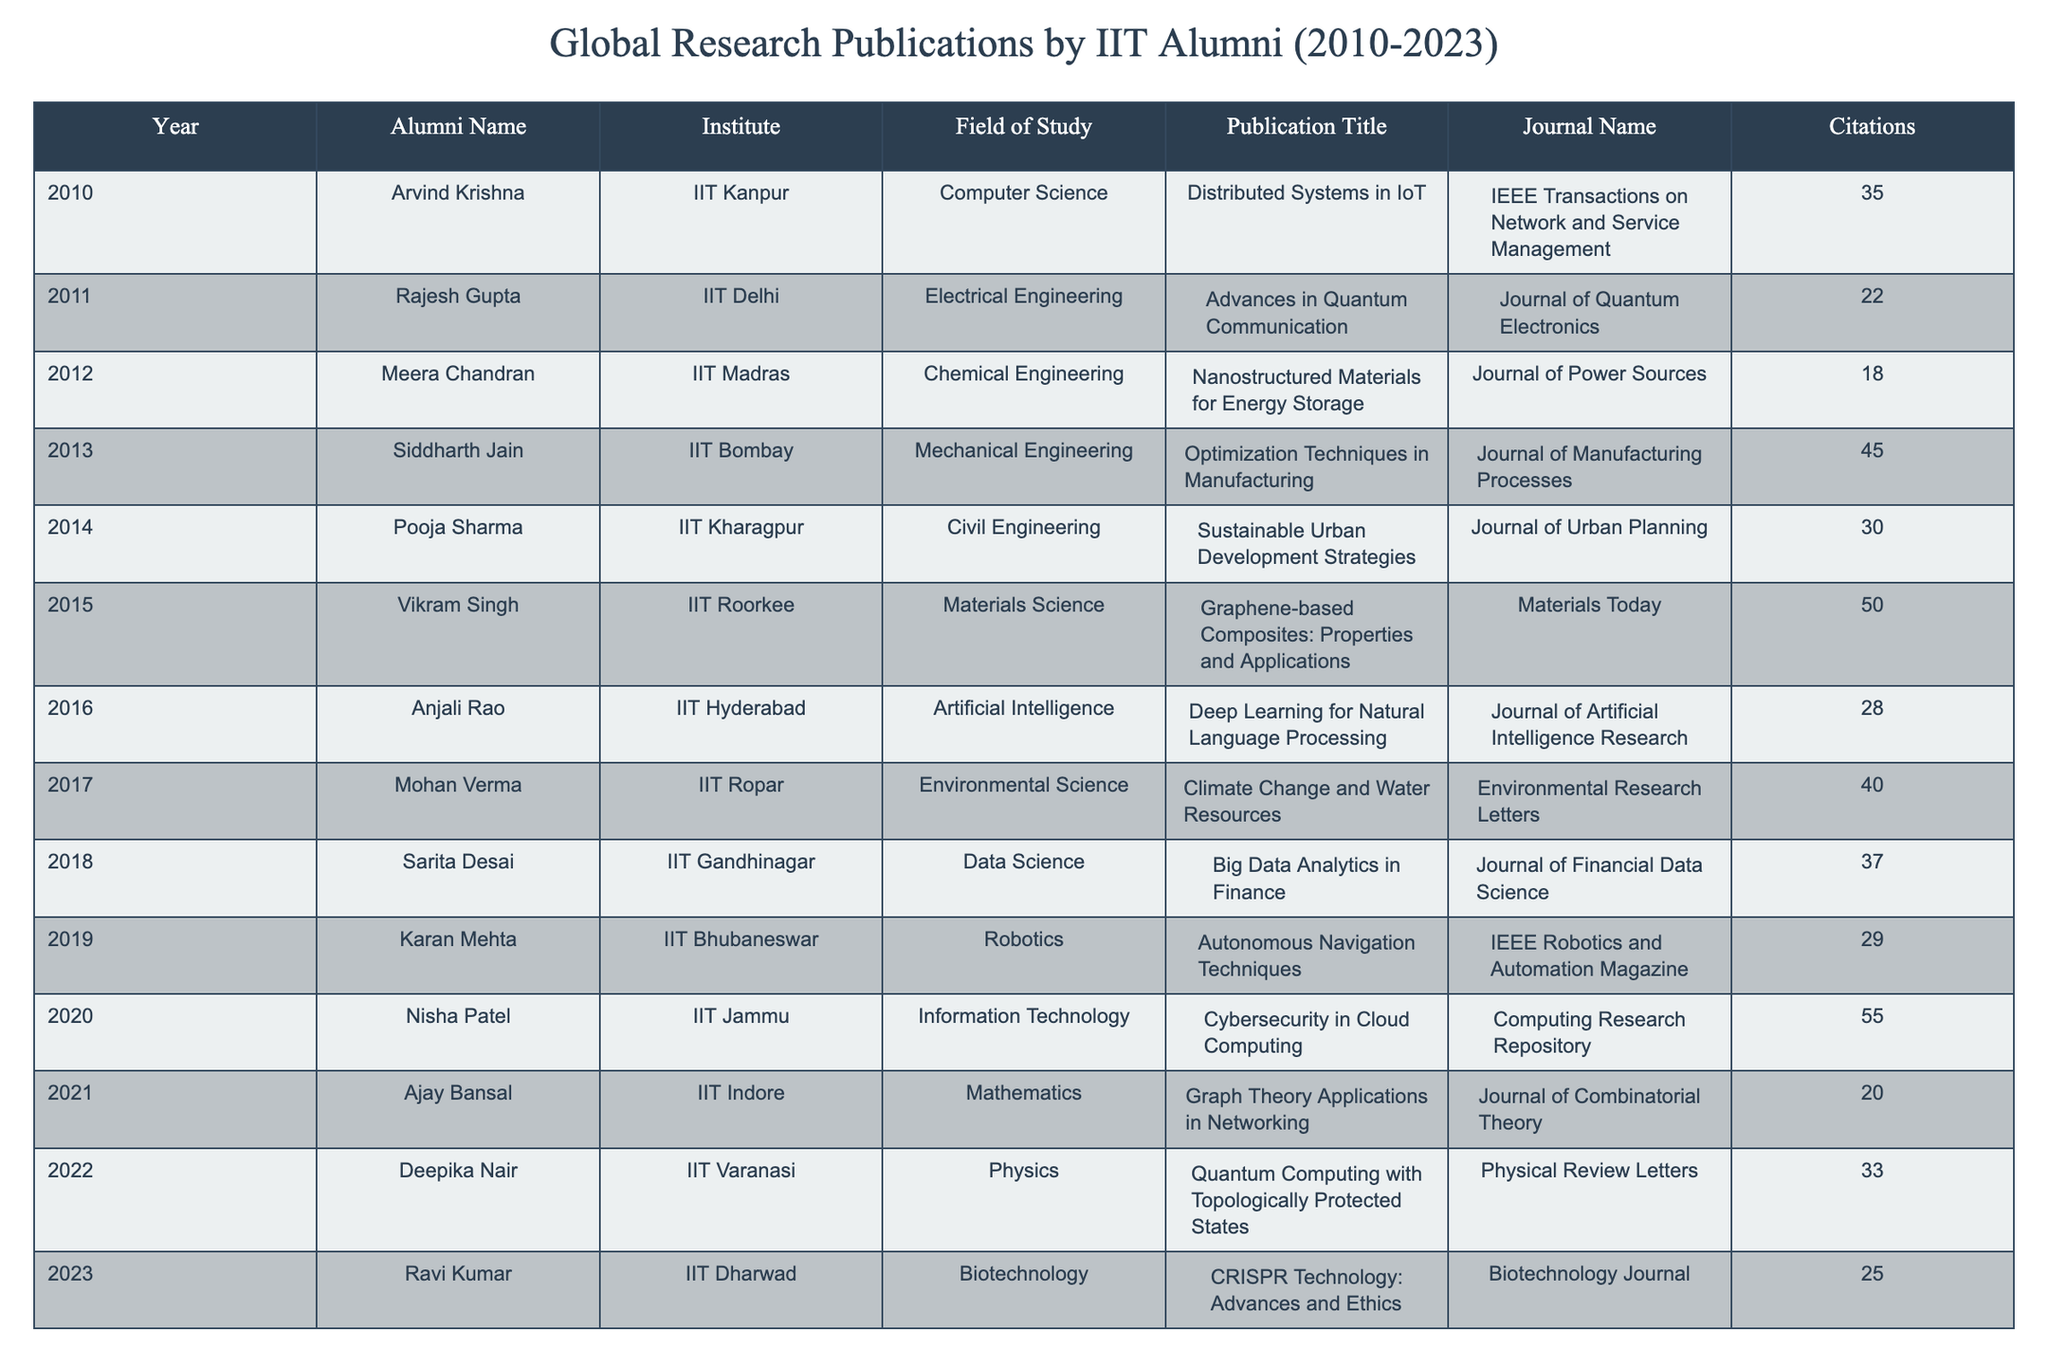What is the publication title by Arvind Krishna? The table lists the publication titles associated with each alumnus. For Arvind Krishna, the publication title under his record is "Distributed Systems in IoT."
Answer: Distributed Systems in IoT Which institute did Nisha Patel attend? By checking the row corresponding to Nisha Patel, we see that her institute is IIT Jammu.
Answer: IIT Jammu How many citations did Vikram Singh receive for his publication? Referring to Vikram Singh's record, the citations column shows that he received 50 citations.
Answer: 50 Can you name the publication that has the highest number of citations? To find this, we check the citations for each publication. The publication by Nisha Patel has the highest citations with a total of 55.
Answer: Cybersecurity in Cloud Computing What is the average number of citations for publications from 2010 to 2023? We sum all citations: 35 + 22 + 18 + 45 + 30 + 50 + 28 + 40 + 37 + 29 + 55 + 20 + 33 + 25 =  397. There are 14 publications, so the average is 397/14 ≈ 28.36.
Answer: 28.36 Was there a publication from IIT Dharwad before 2023? Reviewing the data, we find that there is only one entry from IIT Dharwad, which corresponds to the year 2023. Thus, there is no publication from IIT Dharwad before that year.
Answer: No What is the difference in citations between the publication with the highest and the lowest citations? The highest citation count is 55 (Nisha Patel) and the lowest is 18 (Meera Chandran). The difference is 55 - 18 = 37.
Answer: 37 How many fields of study are represented in the publications? By checking the distinct fields listed, we identify the following unique fields: Computer Science, Electrical Engineering, Chemical Engineering, Mechanical Engineering, Civil Engineering, Materials Science, Artificial Intelligence, Environmental Science, Data Science, Robotics, Information Technology, Mathematics, Physics, and Biotechnology, totaling 14 different fields of study.
Answer: 14 Which year had the most notable rise in citations from previous years based on the data provided? Starting from 2010, we track changes in citation counts each year. While looking closely, in 2020, Nisha Patel's work shows a big leap to 55 citations from an average of around 30 in previous years, thus indicating a notable rise.
Answer: 2020 Is there any alumni from IIT Kanpur who published in the field of Artificial Intelligence? Upon checking the records, Arvind Krishna is the only alumni from IIT Kanpur, and his field of study is Computer Science, not Artificial Intelligence. Therefore, the answer is no.
Answer: No 